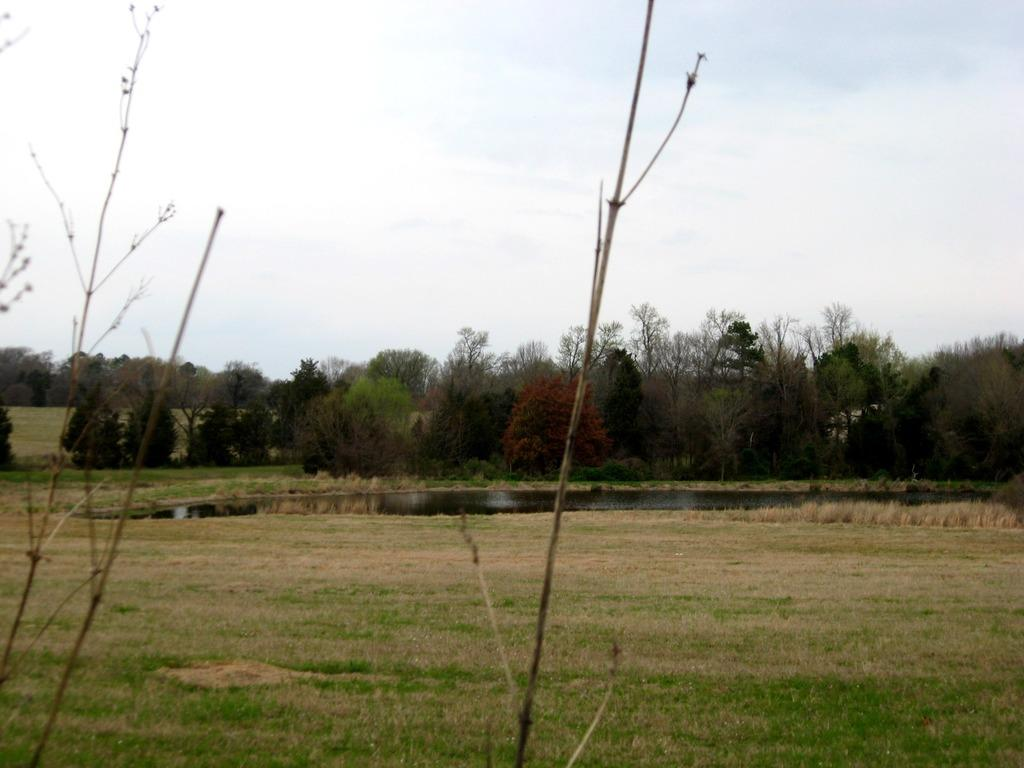What is visible on the ground in the image? The ground is visible in the image. What type of vegetation can be seen in the image? There are trees in the image. What colors are the trees in the image? The trees have red and green colors. What is visible in the background of the image? The sky is visible in the background of the image. What type of animal is participating in the competition in the image? There is no animal or competition present in the image. What is the learning method used by the trees in the image? Trees do not learn in the same way as humans or animals, so this question is not applicable to the image. 